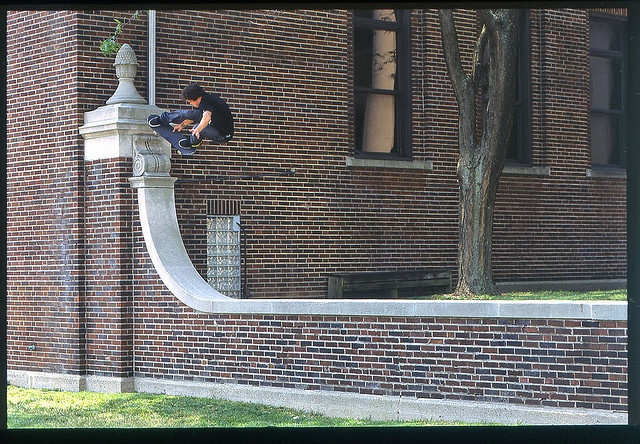Describe the objects in this image and their specific colors. I can see people in black, gray, and darkblue tones, bench in black, gray, and purple tones, and skateboard in black, gray, blue, and navy tones in this image. 